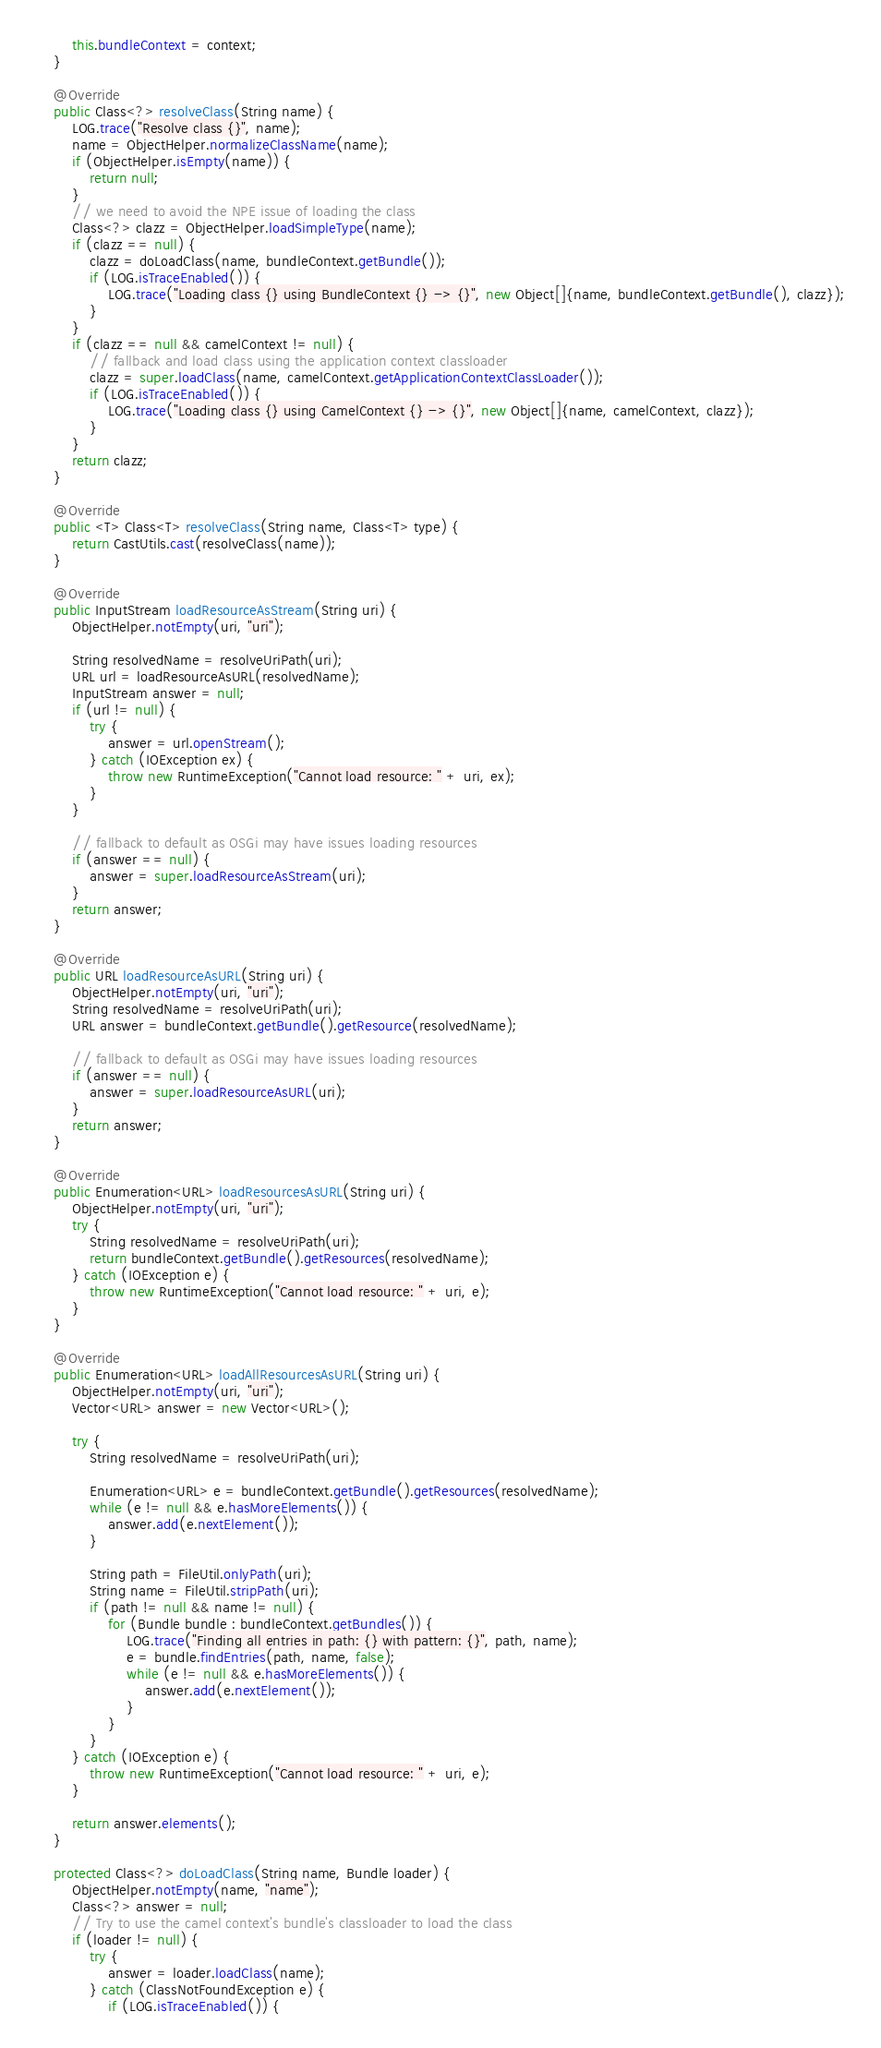<code> <loc_0><loc_0><loc_500><loc_500><_Java_>        this.bundleContext = context;
    }

    @Override
    public Class<?> resolveClass(String name) {
        LOG.trace("Resolve class {}", name);
        name = ObjectHelper.normalizeClassName(name);
        if (ObjectHelper.isEmpty(name)) {
            return null;
        }
        // we need to avoid the NPE issue of loading the class
        Class<?> clazz = ObjectHelper.loadSimpleType(name);
        if (clazz == null) {
            clazz = doLoadClass(name, bundleContext.getBundle());
            if (LOG.isTraceEnabled()) {
                LOG.trace("Loading class {} using BundleContext {} -> {}", new Object[]{name, bundleContext.getBundle(), clazz});
            }
        }
        if (clazz == null && camelContext != null) {
            // fallback and load class using the application context classloader
            clazz = super.loadClass(name, camelContext.getApplicationContextClassLoader());
            if (LOG.isTraceEnabled()) {
                LOG.trace("Loading class {} using CamelContext {} -> {}", new Object[]{name, camelContext, clazz});
            }
        }
        return clazz;
    }

    @Override
    public <T> Class<T> resolveClass(String name, Class<T> type) {
        return CastUtils.cast(resolveClass(name));
    }

    @Override
    public InputStream loadResourceAsStream(String uri) {
        ObjectHelper.notEmpty(uri, "uri");

        String resolvedName = resolveUriPath(uri);
        URL url = loadResourceAsURL(resolvedName);
        InputStream answer = null;
        if (url != null) {
            try {
                answer = url.openStream();
            } catch (IOException ex) {
                throw new RuntimeException("Cannot load resource: " + uri, ex);
            }
        }

        // fallback to default as OSGi may have issues loading resources
        if (answer == null) {
            answer = super.loadResourceAsStream(uri);
        }
        return answer;
    }

    @Override
    public URL loadResourceAsURL(String uri) {
        ObjectHelper.notEmpty(uri, "uri");
        String resolvedName = resolveUriPath(uri);
        URL answer = bundleContext.getBundle().getResource(resolvedName);

        // fallback to default as OSGi may have issues loading resources
        if (answer == null) {
            answer = super.loadResourceAsURL(uri);
        }
        return answer;
    }

    @Override
    public Enumeration<URL> loadResourcesAsURL(String uri) {
        ObjectHelper.notEmpty(uri, "uri");
        try {
            String resolvedName = resolveUriPath(uri);
            return bundleContext.getBundle().getResources(resolvedName);
        } catch (IOException e) {
            throw new RuntimeException("Cannot load resource: " + uri, e);
        }
    }

    @Override
    public Enumeration<URL> loadAllResourcesAsURL(String uri) {
        ObjectHelper.notEmpty(uri, "uri");
        Vector<URL> answer = new Vector<URL>();

        try {
            String resolvedName = resolveUriPath(uri);

            Enumeration<URL> e = bundleContext.getBundle().getResources(resolvedName);
            while (e != null && e.hasMoreElements()) {
                answer.add(e.nextElement());
            }

            String path = FileUtil.onlyPath(uri);
            String name = FileUtil.stripPath(uri);
            if (path != null && name != null) {
                for (Bundle bundle : bundleContext.getBundles()) {
                    LOG.trace("Finding all entries in path: {} with pattern: {}", path, name);
                    e = bundle.findEntries(path, name, false);
                    while (e != null && e.hasMoreElements()) {
                        answer.add(e.nextElement());
                    }
                }
            }
        } catch (IOException e) {
            throw new RuntimeException("Cannot load resource: " + uri, e);
        }

        return answer.elements();
    }

    protected Class<?> doLoadClass(String name, Bundle loader) {
        ObjectHelper.notEmpty(name, "name");
        Class<?> answer = null;
        // Try to use the camel context's bundle's classloader to load the class
        if (loader != null) {
            try {
                answer = loader.loadClass(name);
            } catch (ClassNotFoundException e) {
                if (LOG.isTraceEnabled()) {</code> 